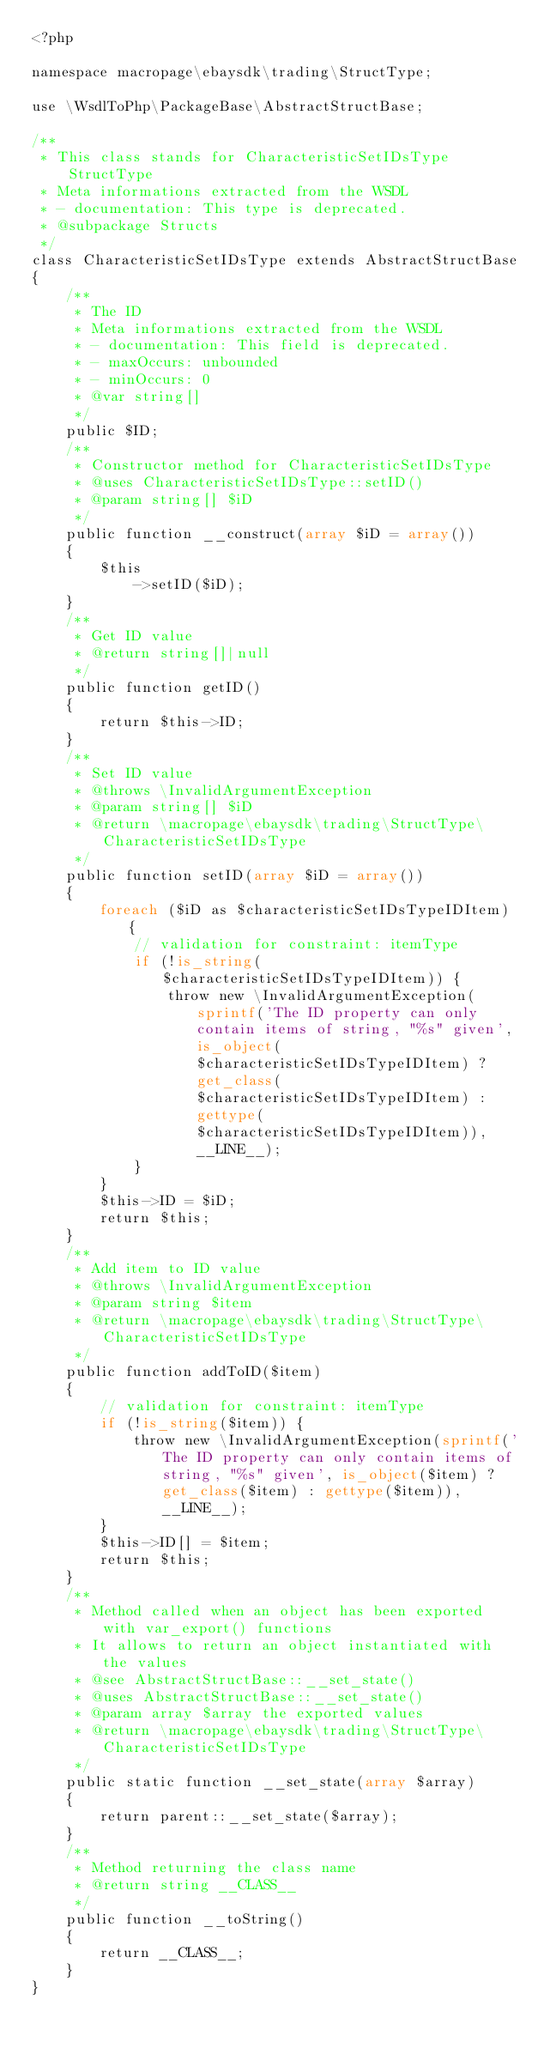Convert code to text. <code><loc_0><loc_0><loc_500><loc_500><_PHP_><?php

namespace macropage\ebaysdk\trading\StructType;

use \WsdlToPhp\PackageBase\AbstractStructBase;

/**
 * This class stands for CharacteristicSetIDsType StructType
 * Meta informations extracted from the WSDL
 * - documentation: This type is deprecated.
 * @subpackage Structs
 */
class CharacteristicSetIDsType extends AbstractStructBase
{
    /**
     * The ID
     * Meta informations extracted from the WSDL
     * - documentation: This field is deprecated.
     * - maxOccurs: unbounded
     * - minOccurs: 0
     * @var string[]
     */
    public $ID;
    /**
     * Constructor method for CharacteristicSetIDsType
     * @uses CharacteristicSetIDsType::setID()
     * @param string[] $iD
     */
    public function __construct(array $iD = array())
    {
        $this
            ->setID($iD);
    }
    /**
     * Get ID value
     * @return string[]|null
     */
    public function getID()
    {
        return $this->ID;
    }
    /**
     * Set ID value
     * @throws \InvalidArgumentException
     * @param string[] $iD
     * @return \macropage\ebaysdk\trading\StructType\CharacteristicSetIDsType
     */
    public function setID(array $iD = array())
    {
        foreach ($iD as $characteristicSetIDsTypeIDItem) {
            // validation for constraint: itemType
            if (!is_string($characteristicSetIDsTypeIDItem)) {
                throw new \InvalidArgumentException(sprintf('The ID property can only contain items of string, "%s" given', is_object($characteristicSetIDsTypeIDItem) ? get_class($characteristicSetIDsTypeIDItem) : gettype($characteristicSetIDsTypeIDItem)), __LINE__);
            }
        }
        $this->ID = $iD;
        return $this;
    }
    /**
     * Add item to ID value
     * @throws \InvalidArgumentException
     * @param string $item
     * @return \macropage\ebaysdk\trading\StructType\CharacteristicSetIDsType
     */
    public function addToID($item)
    {
        // validation for constraint: itemType
        if (!is_string($item)) {
            throw new \InvalidArgumentException(sprintf('The ID property can only contain items of string, "%s" given', is_object($item) ? get_class($item) : gettype($item)), __LINE__);
        }
        $this->ID[] = $item;
        return $this;
    }
    /**
     * Method called when an object has been exported with var_export() functions
     * It allows to return an object instantiated with the values
     * @see AbstractStructBase::__set_state()
     * @uses AbstractStructBase::__set_state()
     * @param array $array the exported values
     * @return \macropage\ebaysdk\trading\StructType\CharacteristicSetIDsType
     */
    public static function __set_state(array $array)
    {
        return parent::__set_state($array);
    }
    /**
     * Method returning the class name
     * @return string __CLASS__
     */
    public function __toString()
    {
        return __CLASS__;
    }
}
</code> 